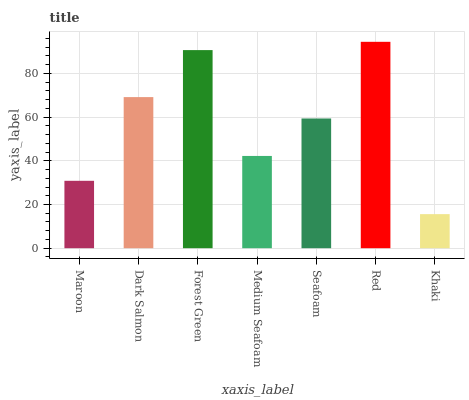Is Khaki the minimum?
Answer yes or no. Yes. Is Red the maximum?
Answer yes or no. Yes. Is Dark Salmon the minimum?
Answer yes or no. No. Is Dark Salmon the maximum?
Answer yes or no. No. Is Dark Salmon greater than Maroon?
Answer yes or no. Yes. Is Maroon less than Dark Salmon?
Answer yes or no. Yes. Is Maroon greater than Dark Salmon?
Answer yes or no. No. Is Dark Salmon less than Maroon?
Answer yes or no. No. Is Seafoam the high median?
Answer yes or no. Yes. Is Seafoam the low median?
Answer yes or no. Yes. Is Khaki the high median?
Answer yes or no. No. Is Khaki the low median?
Answer yes or no. No. 